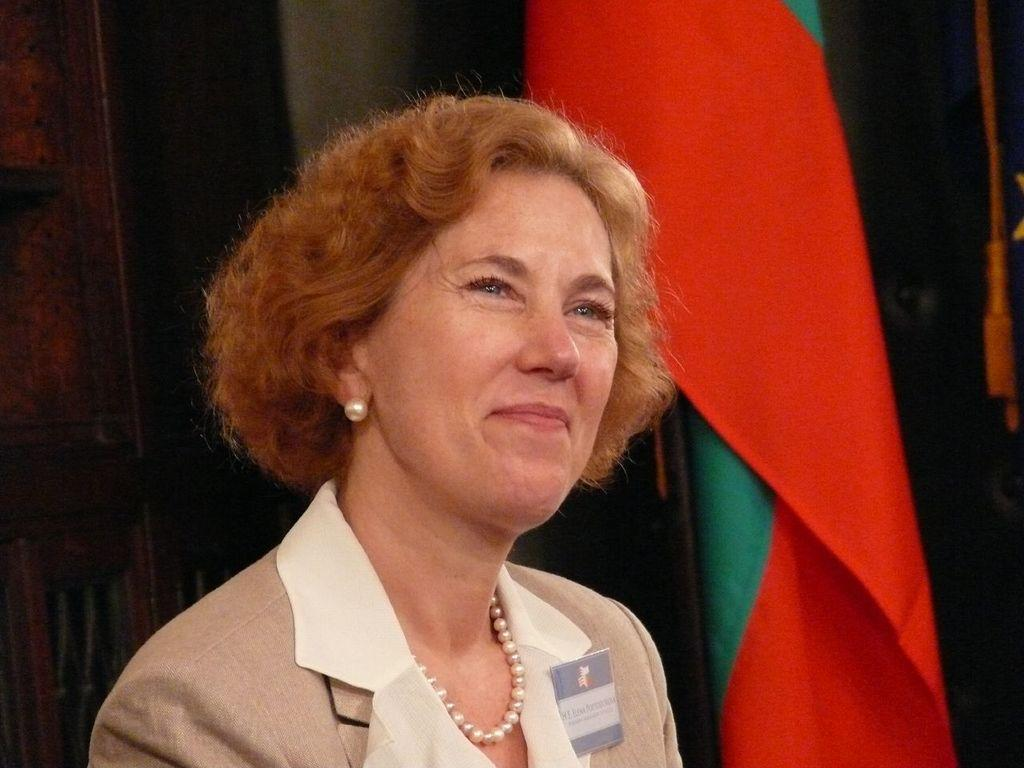What is the main subject in the foreground of the image? There is a person in the foreground of the image. What is the person wearing? The person is wearing a blazer. What is the person's facial expression? The person is smiling. What can be seen in the background of the image? There is a wall, a flag, and other objects visible in the background of the image. What type of instrument is the person playing in the image? There is no instrument present in the image; the person is not playing any instrument. 